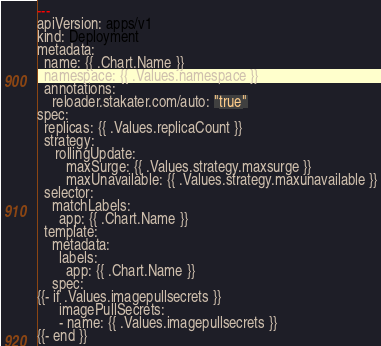<code> <loc_0><loc_0><loc_500><loc_500><_YAML_>---
apiVersion: apps/v1
kind: Deployment
metadata:
  name: {{ .Chart.Name }}
  namespace: {{ .Values.namespace }}
  annotations:
    reloader.stakater.com/auto: "true"
spec:
  replicas: {{ .Values.replicaCount }}
  strategy:
     rollingUpdate:
        maxSurge: {{ .Values.strategy.maxsurge }}
        maxUnavailable: {{ .Values.strategy.maxunavailable }}
  selector:
    matchLabels:
      app: {{ .Chart.Name }}
  template:
    metadata:
      labels:
        app: {{ .Chart.Name }}
    spec:
{{- if .Values.imagepullsecrets }}
      imagePullSecrets:
      - name: {{ .Values.imagepullsecrets }}
{{- end }}</code> 